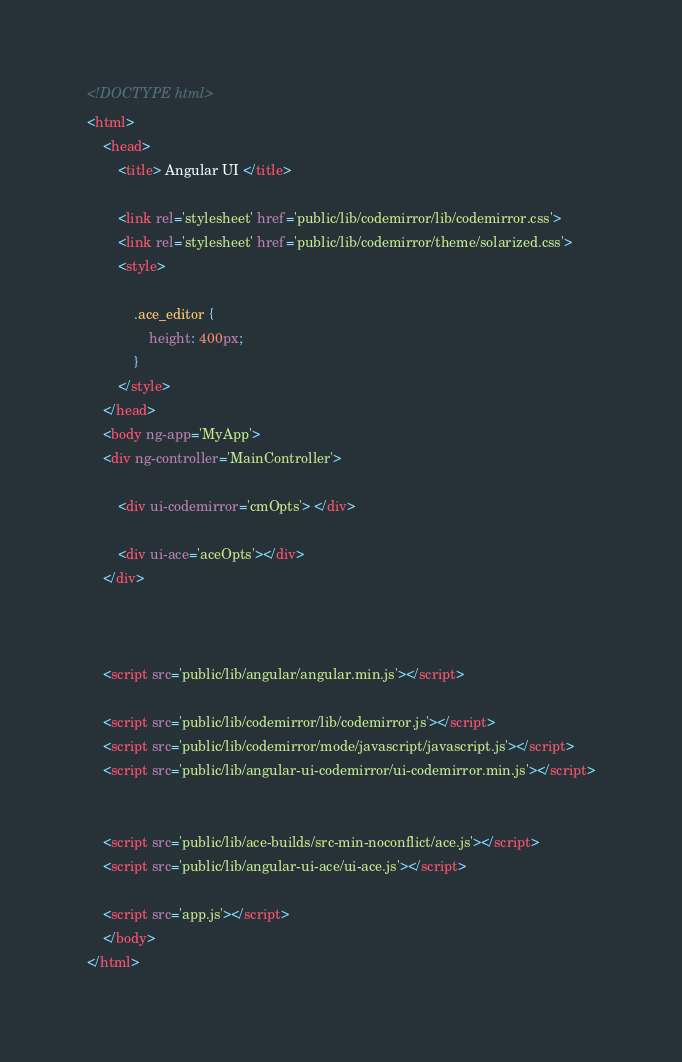<code> <loc_0><loc_0><loc_500><loc_500><_HTML_><!DOCTYPE html>
<html>
    <head>
        <title> Angular UI </title>

        <link rel='stylesheet' href='public/lib/codemirror/lib/codemirror.css'>
        <link rel='stylesheet' href='public/lib/codemirror/theme/solarized.css'>
        <style>

            .ace_editor {
                height: 400px; 
            }
        </style>
    </head>
    <body ng-app='MyApp'>
    <div ng-controller='MainController'>
    
        <div ui-codemirror='cmOpts'> </div>

        <div ui-ace='aceOpts'></div>
    </div>



    <script src='public/lib/angular/angular.min.js'></script>

    <script src='public/lib/codemirror/lib/codemirror.js'></script>
    <script src='public/lib/codemirror/mode/javascript/javascript.js'></script>
    <script src='public/lib/angular-ui-codemirror/ui-codemirror.min.js'></script>


    <script src='public/lib/ace-builds/src-min-noconflict/ace.js'></script>
    <script src='public/lib/angular-ui-ace/ui-ace.js'></script>

    <script src='app.js'></script>
    </body>
</html>
</code> 